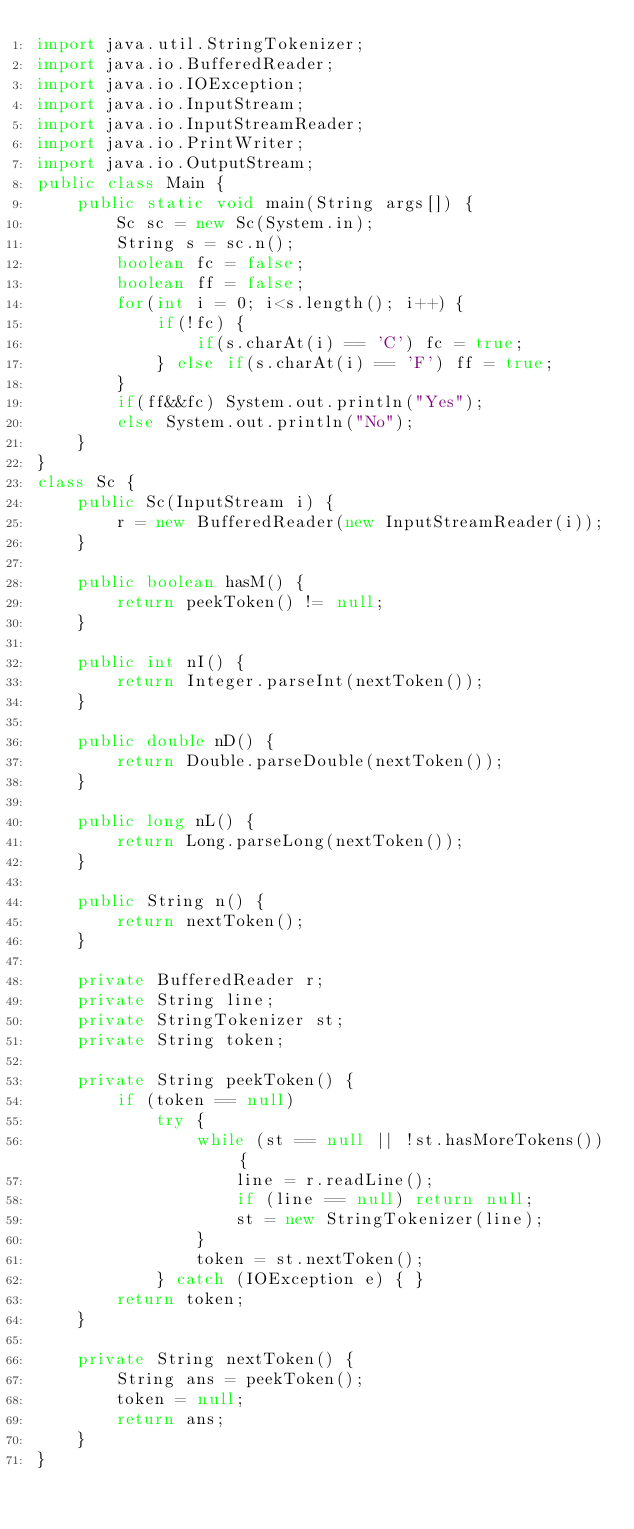<code> <loc_0><loc_0><loc_500><loc_500><_Java_>import java.util.StringTokenizer;
import java.io.BufferedReader;
import java.io.IOException;
import java.io.InputStream;
import java.io.InputStreamReader;
import java.io.PrintWriter;
import java.io.OutputStream;
public class Main {
    public static void main(String args[]) {
        Sc sc = new Sc(System.in);
        String s = sc.n();
        boolean fc = false;
        boolean ff = false;
        for(int i = 0; i<s.length(); i++) {
            if(!fc) {
                if(s.charAt(i) == 'C') fc = true;
            } else if(s.charAt(i) == 'F') ff = true;
        }
        if(ff&&fc) System.out.println("Yes");
        else System.out.println("No");
    }
}
class Sc {
    public Sc(InputStream i) {
        r = new BufferedReader(new InputStreamReader(i));
    }

    public boolean hasM() {
        return peekToken() != null;
    }

    public int nI() {
        return Integer.parseInt(nextToken());
    }

    public double nD() { 
        return Double.parseDouble(nextToken());
    }

    public long nL() {
        return Long.parseLong(nextToken());
    }

    public String n() {
        return nextToken();
    }

    private BufferedReader r;
    private String line;
    private StringTokenizer st;
    private String token;

    private String peekToken() {
        if (token == null) 
            try {
                while (st == null || !st.hasMoreTokens()) {
                    line = r.readLine();
                    if (line == null) return null;
                    st = new StringTokenizer(line);
                }
                token = st.nextToken();
            } catch (IOException e) { }
        return token;
    }

    private String nextToken() {
        String ans = peekToken();
        token = null;
        return ans;
    }
}</code> 